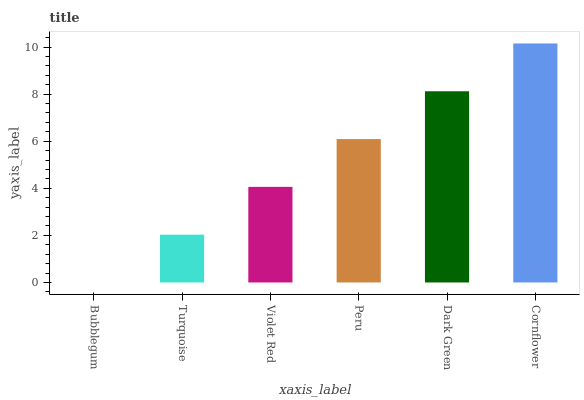Is Bubblegum the minimum?
Answer yes or no. Yes. Is Cornflower the maximum?
Answer yes or no. Yes. Is Turquoise the minimum?
Answer yes or no. No. Is Turquoise the maximum?
Answer yes or no. No. Is Turquoise greater than Bubblegum?
Answer yes or no. Yes. Is Bubblegum less than Turquoise?
Answer yes or no. Yes. Is Bubblegum greater than Turquoise?
Answer yes or no. No. Is Turquoise less than Bubblegum?
Answer yes or no. No. Is Peru the high median?
Answer yes or no. Yes. Is Violet Red the low median?
Answer yes or no. Yes. Is Turquoise the high median?
Answer yes or no. No. Is Bubblegum the low median?
Answer yes or no. No. 